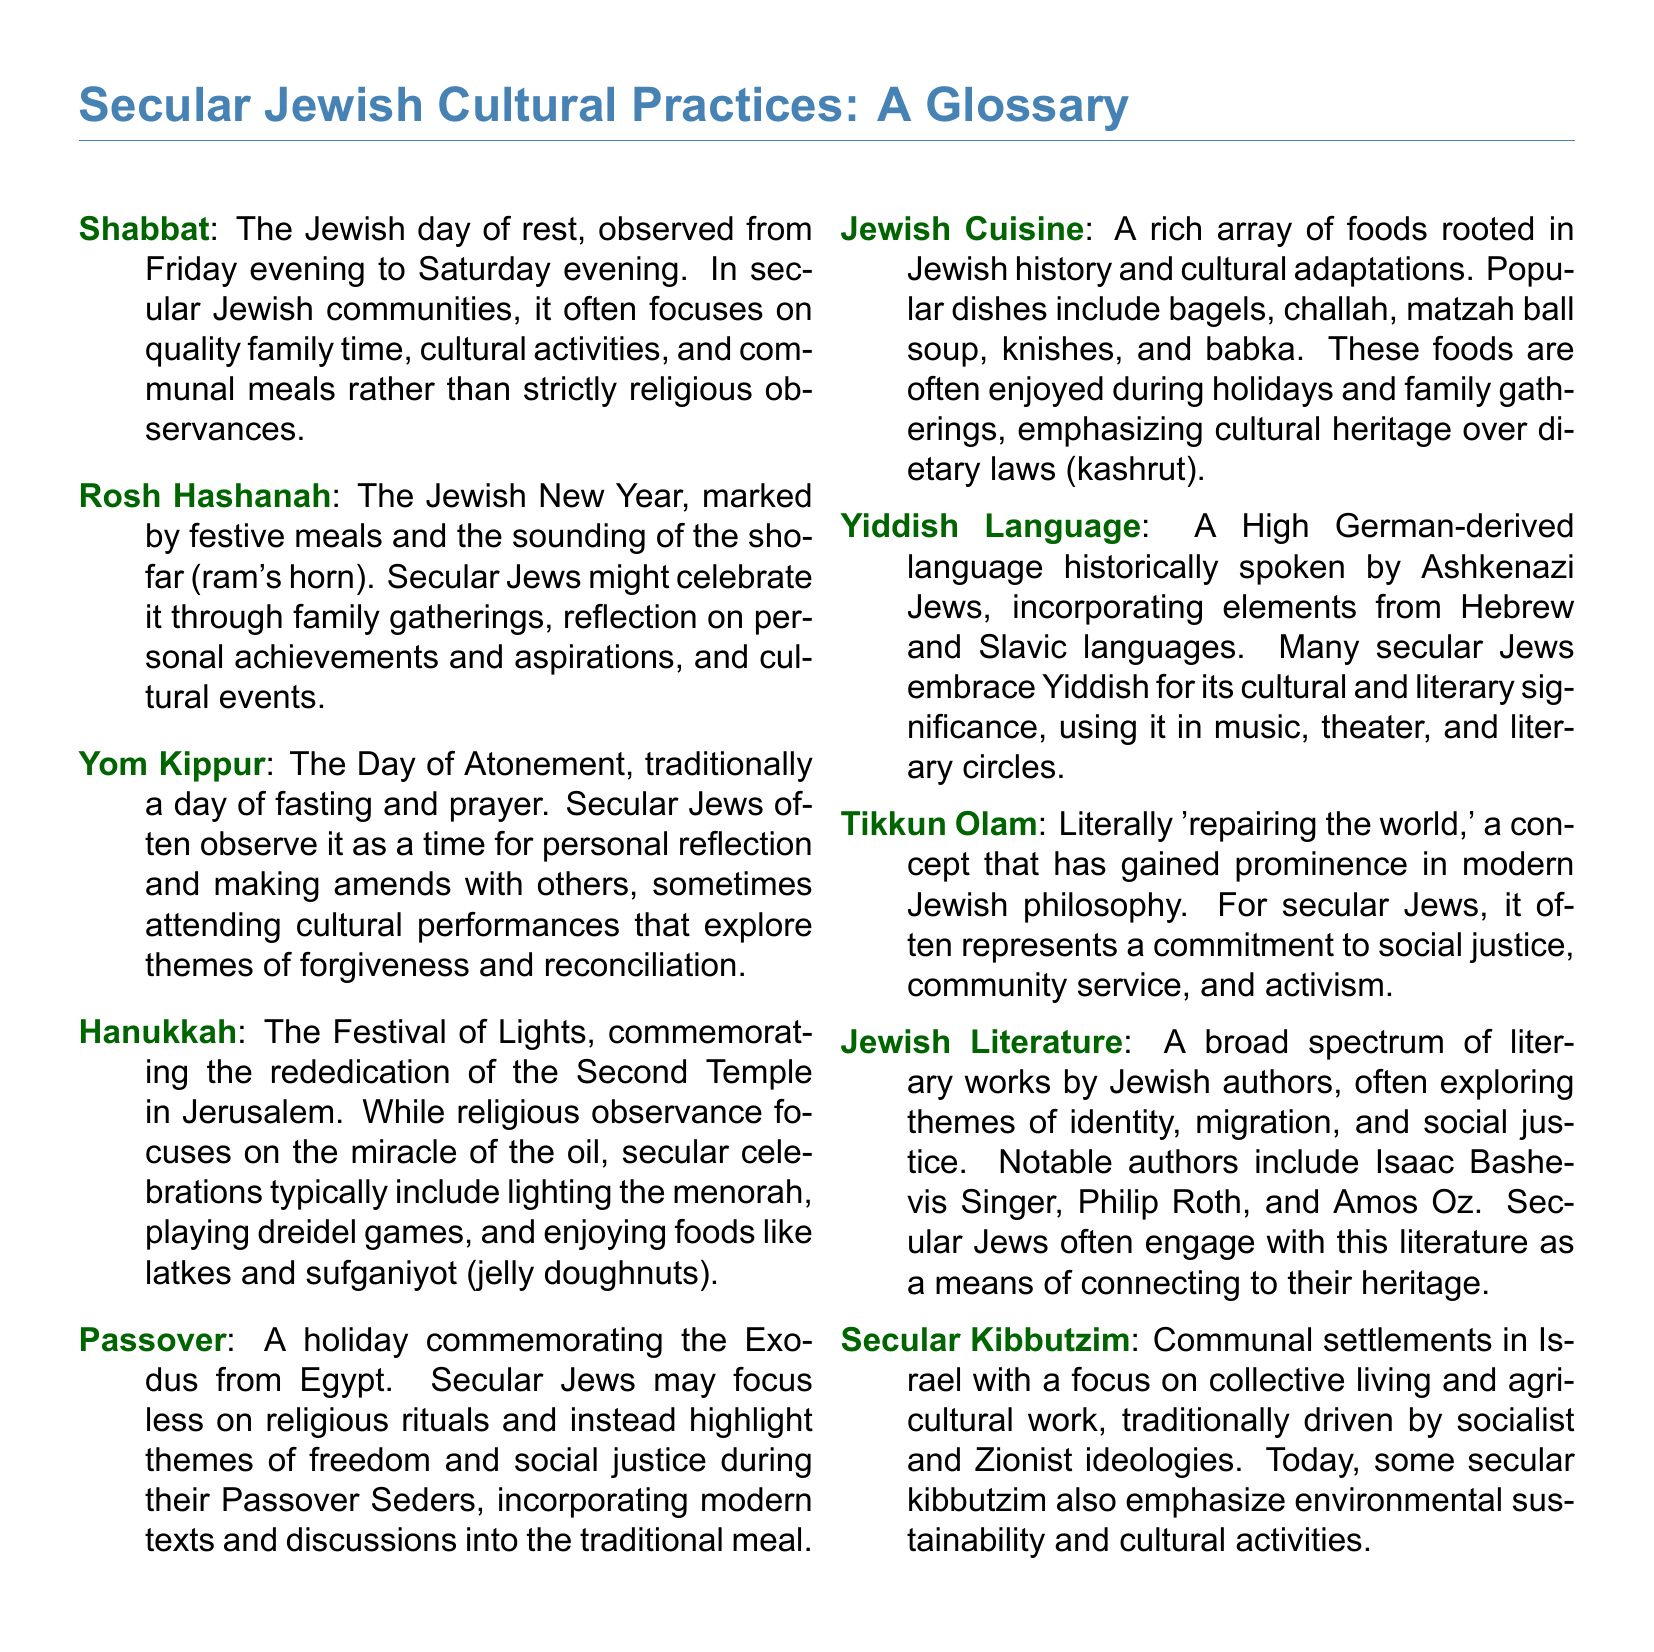What is the Jewish day of rest? The document defines Shabbat as the Jewish day of rest, observed from Friday evening to Saturday evening.
Answer: Shabbat What holiday is marked by the sounding of the shofar? The document states that Rosh Hashanah is marked by the sounding of the shofar (ram's horn).
Answer: Rosh Hashanah What food is commonly associated with Hanukkah? The glossary mentions that latkes and sufganiyot (jelly doughnuts) are popular foods during Hanukkah celebrations.
Answer: Latkes, sufganiyot What concept refers to 'repairing the world'? The term Tikkun Olam is explained in the document as 'repairing the world.'
Answer: Tikkun Olam What is a secular kibbutz? The document describes secular kibbutzim as communal settlements in Israel with a focus on collective living and agricultural work.
Answer: Communal settlements What is the focus of secular Passover Seders? The glossary indicates that secular Jews might highlight themes of freedom and social justice during their Passover Seders.
Answer: Freedom and social justice Who is a notable Jewish author mentioned in the document? The document lists Isaac Bashevis Singer as a notable author in Jewish literature.
Answer: Isaac Bashevis Singer What language is historically spoken by Ashkenazi Jews? The glossary states that Yiddish is a language historically spoken by Ashkenazi Jews.
Answer: Yiddish How do secular Jews typically engage with Jewish cuisine? The document notes that secular Jews enjoy traditional foods emphasizing cultural heritage rather than dietary laws.
Answer: Cultural heritage 